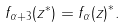<formula> <loc_0><loc_0><loc_500><loc_500>f _ { \alpha + 3 } ( z ^ { * } ) = { f _ { \alpha } ( z ) } ^ { * } .</formula> 